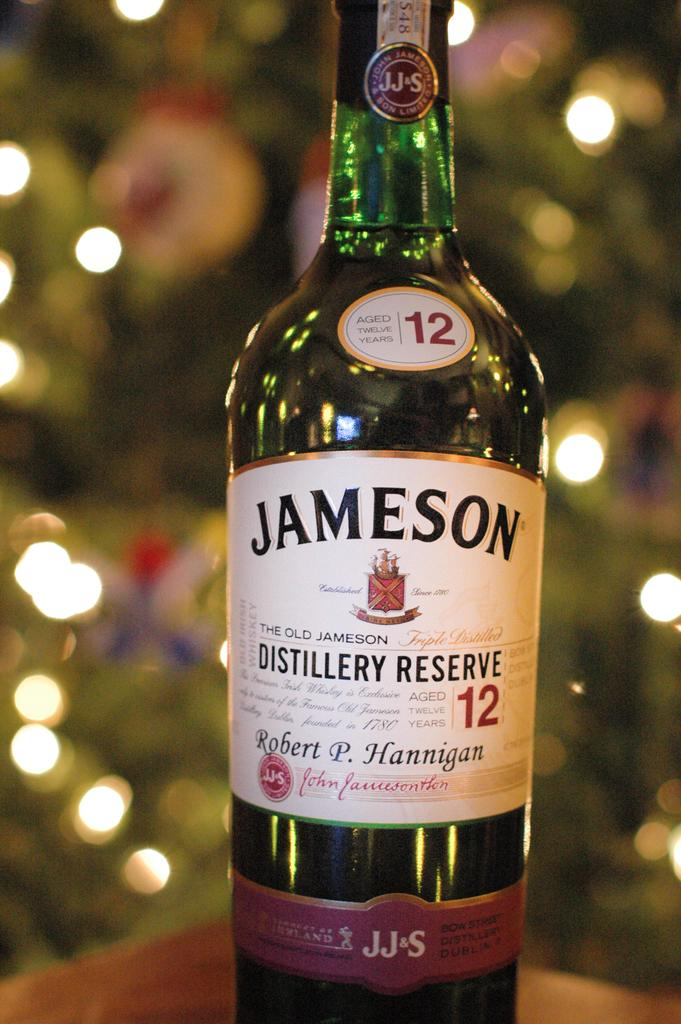Provide a one-sentence caption for the provided image. the word Jameson that is on a bottle. 